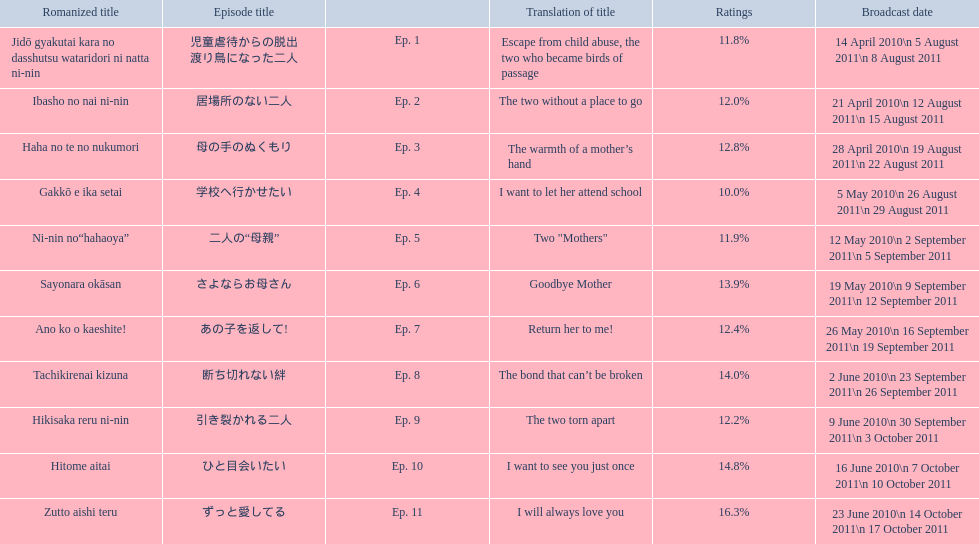What are all the titles the episodes of the mother tv series? 児童虐待からの脱出 渡り鳥になった二人, 居場所のない二人, 母の手のぬくもり, 学校へ行かせたい, 二人の“母親”, さよならお母さん, あの子を返して!, 断ち切れない絆, 引き裂かれる二人, ひと目会いたい, ずっと愛してる. What are all of the ratings for each of the shows? 11.8%, 12.0%, 12.8%, 10.0%, 11.9%, 13.9%, 12.4%, 14.0%, 12.2%, 14.8%, 16.3%. What is the highest score for ratings? 16.3%. What episode corresponds to that rating? ずっと愛してる. 